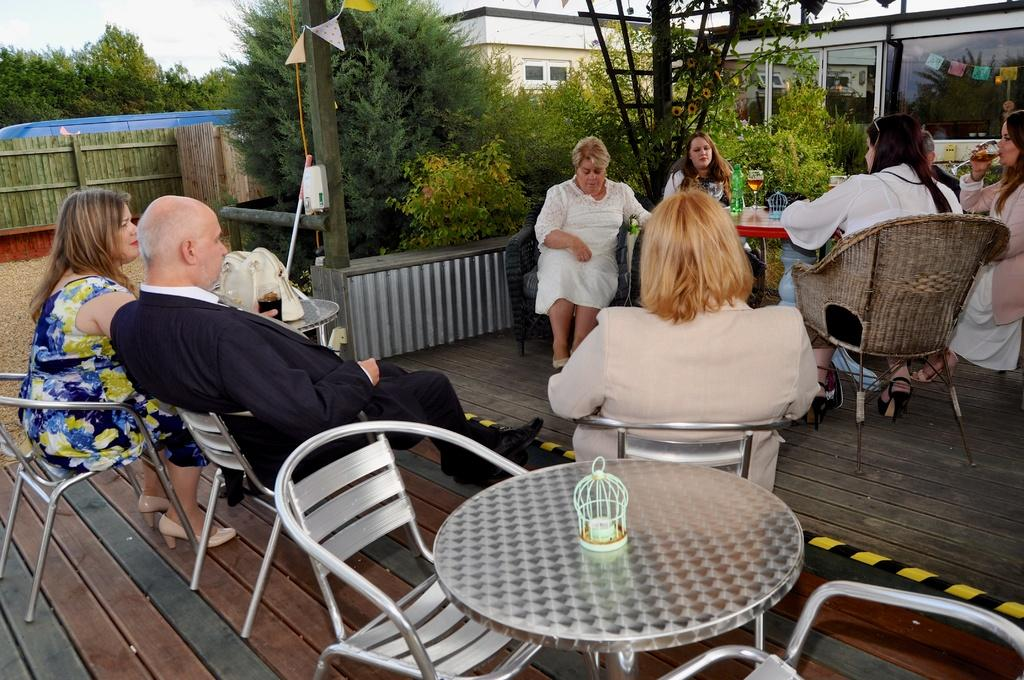How many people are in the image? There is a group of people in the image. What are the people doing in the image? The people are sitting on chairs. What is on the table in the image? There are drinks present on the table. What else can be seen in the image besides the people and table? There are plants visible in the image. Is there a beggar asking for money in the image? There is no beggar present in the image. What type of prose is being recited by the people in the image? There is no indication of any prose being recited in the image; the people are simply sitting on chairs. 